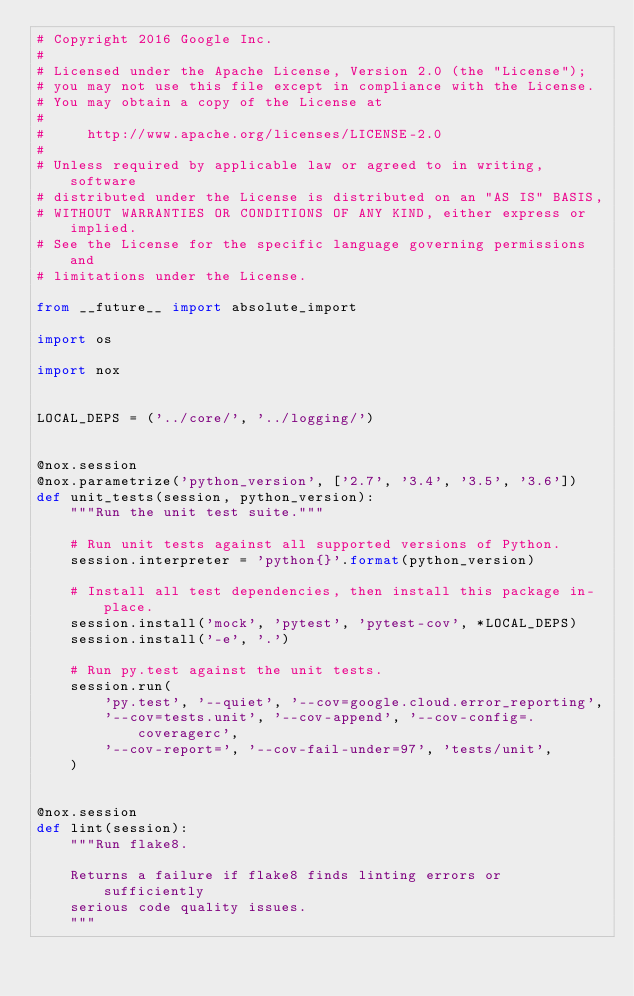<code> <loc_0><loc_0><loc_500><loc_500><_Python_># Copyright 2016 Google Inc.
#
# Licensed under the Apache License, Version 2.0 (the "License");
# you may not use this file except in compliance with the License.
# You may obtain a copy of the License at
#
#     http://www.apache.org/licenses/LICENSE-2.0
#
# Unless required by applicable law or agreed to in writing, software
# distributed under the License is distributed on an "AS IS" BASIS,
# WITHOUT WARRANTIES OR CONDITIONS OF ANY KIND, either express or implied.
# See the License for the specific language governing permissions and
# limitations under the License.

from __future__ import absolute_import

import os

import nox


LOCAL_DEPS = ('../core/', '../logging/')


@nox.session
@nox.parametrize('python_version', ['2.7', '3.4', '3.5', '3.6'])
def unit_tests(session, python_version):
    """Run the unit test suite."""

    # Run unit tests against all supported versions of Python.
    session.interpreter = 'python{}'.format(python_version)

    # Install all test dependencies, then install this package in-place.
    session.install('mock', 'pytest', 'pytest-cov', *LOCAL_DEPS)
    session.install('-e', '.')

    # Run py.test against the unit tests.
    session.run(
        'py.test', '--quiet', '--cov=google.cloud.error_reporting',
        '--cov=tests.unit', '--cov-append', '--cov-config=.coveragerc',
        '--cov-report=', '--cov-fail-under=97', 'tests/unit',
    )


@nox.session
def lint(session):
    """Run flake8.

    Returns a failure if flake8 finds linting errors or sufficiently
    serious code quality issues.
    """</code> 